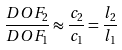Convert formula to latex. <formula><loc_0><loc_0><loc_500><loc_500>\frac { D O F _ { 2 } } { D O F _ { 1 } } \approx \frac { c _ { 2 } } { c _ { 1 } } = \frac { l _ { 2 } } { l _ { 1 } }</formula> 